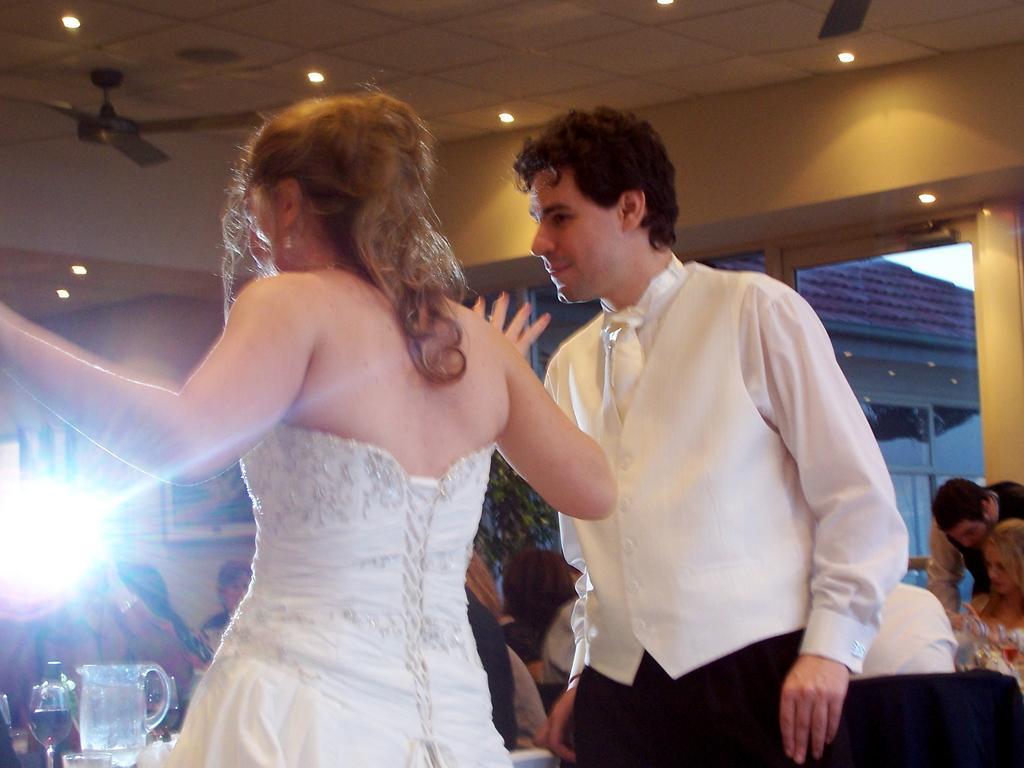Describe this image in one or two sentences. It looks like a restaurant, there are two people standing in the front and behind them many other people were sitting around the tables and on the tables there are many glasses, jugs. In the background there is a photo frame kept to the wall and beside the wall there is a plant. Behind the plant there is a window. 